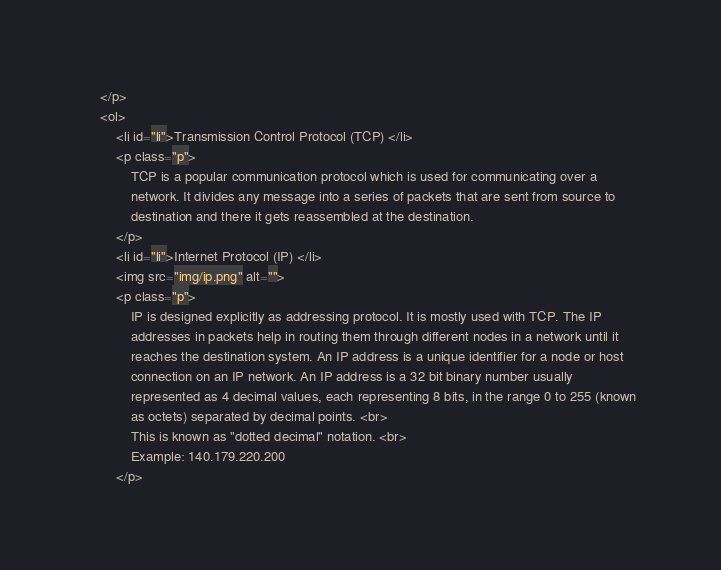<code> <loc_0><loc_0><loc_500><loc_500><_HTML_>    </p>
    <ol>
        <li id="li">Transmission Control Protocol (TCP) </li>
        <p class="p">
            TCP is a popular communication protocol which is used for communicating over a
            network. It divides any message into a series of packets that are sent from source to
            destination and there it gets reassembled at the destination.
        </p>
        <li id="li">Internet Protocol (IP) </li>
        <img src="img/ip.png" alt="">
        <p class="p">
            IP is designed explicitly as addressing protocol. It is mostly used with TCP. The IP
            addresses in packets help in routing them through different nodes in a network until it
            reaches the destination system. An IP address is a unique identifier for a node or host
            connection on an IP network. An IP address is a 32 bit binary number usually
            represented as 4 decimal values, each representing 8 bits, in the range 0 to 255 (known
            as octets) separated by decimal points. <br>
            This is known as "dotted decimal" notation. <br>
            Example: 140.179.220.200
        </p></code> 